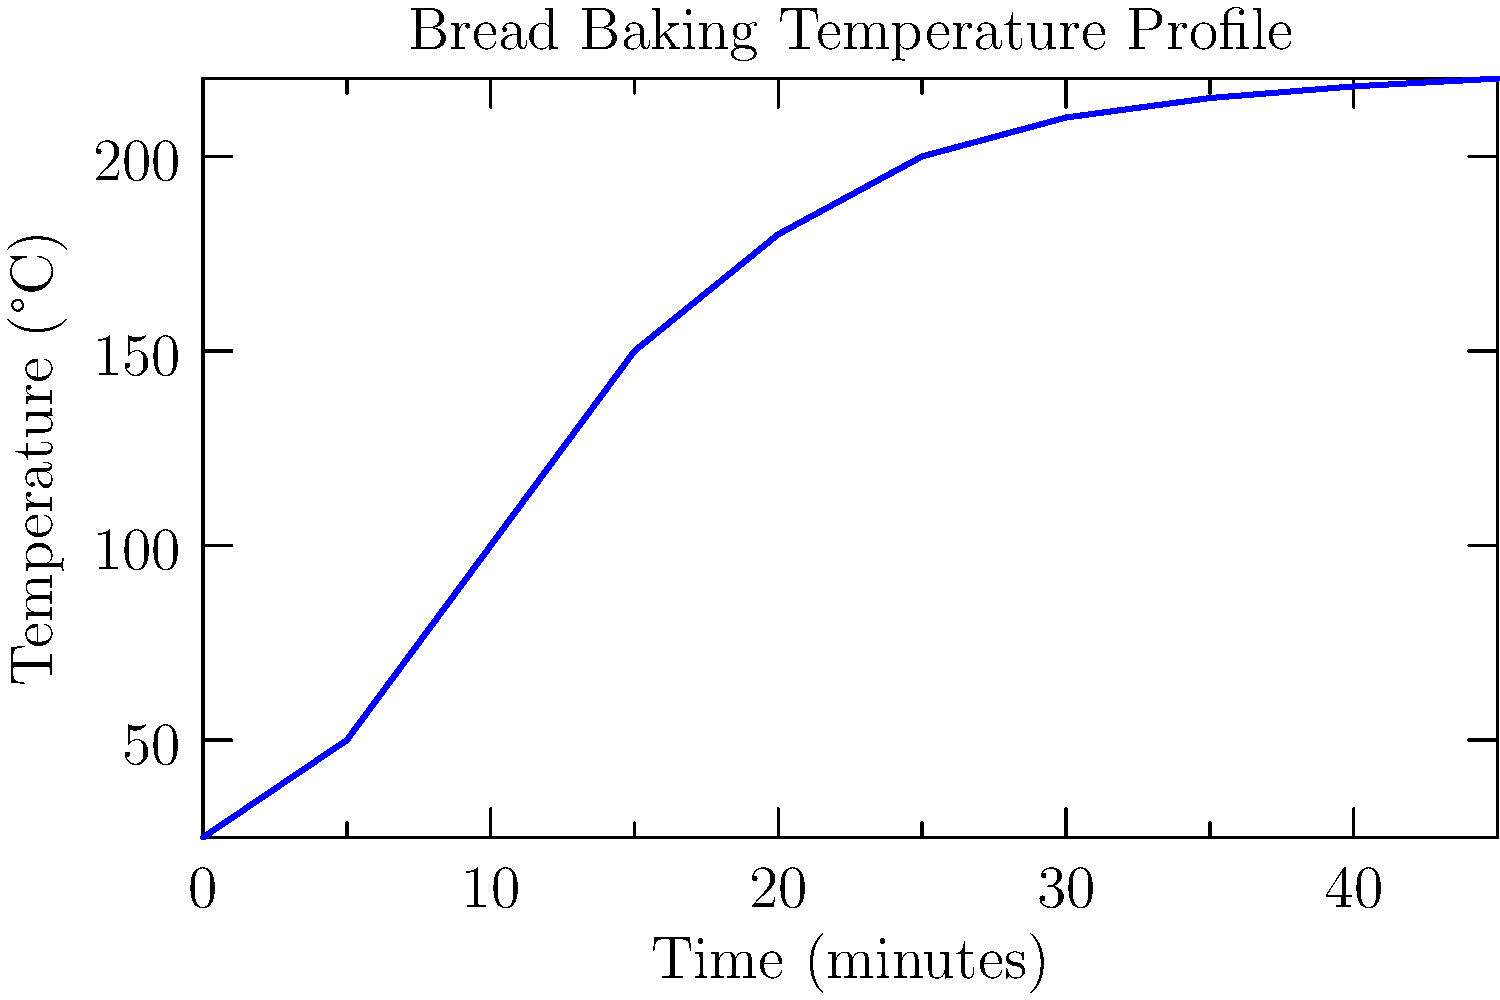Based on the line graph showing the temperature changes during bread baking, at approximately what time does the rate of temperature increase start to slow down significantly? To determine when the rate of temperature increase starts to slow down significantly, we need to analyze the slope of the line graph:

1. From 0 to 15 minutes, the temperature rises rapidly from 25°C to 150°C.
2. Between 15 and 25 minutes, the rate of increase is still relatively high, reaching 200°C.
3. After 25 minutes, we can observe that the line begins to level off, indicating a significant decrease in the rate of temperature change.
4. The slope of the line becomes much less steep from this point onwards.
5. Between 25 and 45 minutes, the temperature only increases by about 20°C, compared to the much larger increases in earlier time intervals.

Therefore, the rate of temperature increase starts to slow down significantly at approximately 25 minutes into the baking process.
Answer: 25 minutes 